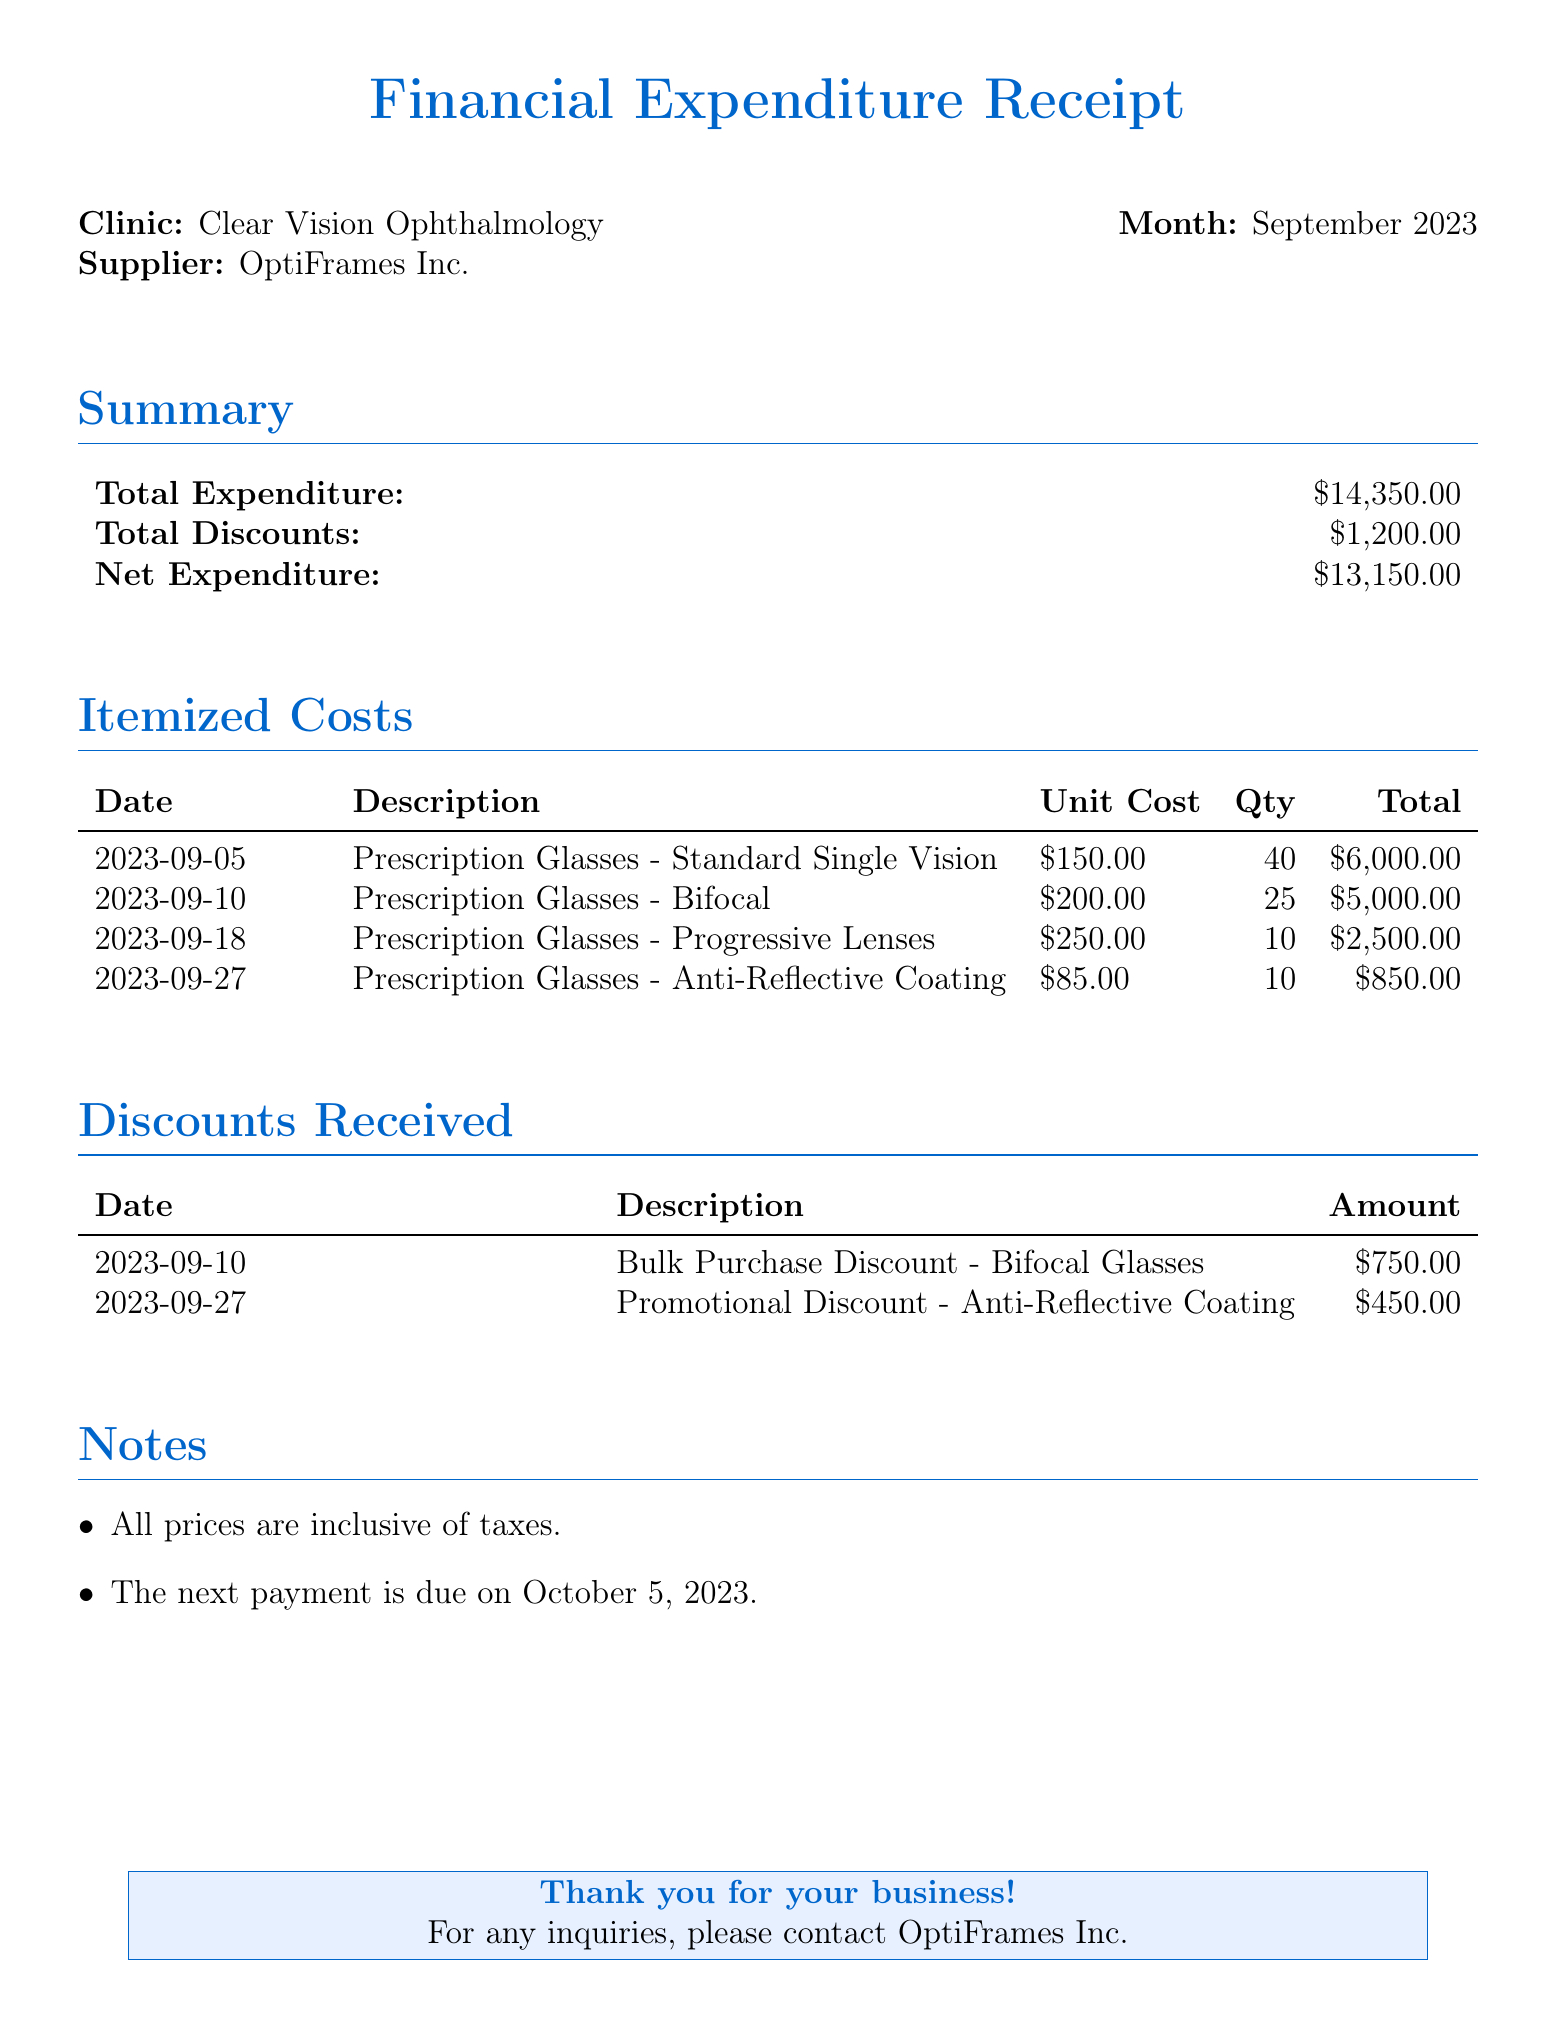What is the total expenditure? The total expenditure is listed in the summary section of the document.
Answer: $14,350.00 What is the net expenditure? The net expenditure is the total expenditure minus total discounts, as shown in the summary.
Answer: $13,150.00 Who is the supplier? The supplier's name is mentioned at the top of the document.
Answer: OptiFrames Inc What was the unit cost of bifocal glasses? The unit cost for bifocal glasses can be found in the itemized costs section.
Answer: $200.00 How many prescription glasses were purchased with anti-reflective coating? The quantity for anti-reflective coating glasses is listed in the itemized costs table.
Answer: 10 What date was the bulk purchase discount received? The date is specified in the discounts received section of the document.
Answer: 2023-09-10 What is the total amount of discounts received? The total discounts can be calculated by adding all the amounts listed in the discounts section.
Answer: $1,200.00 What type of document is this? This document provides a summary of financial expenditures related to purchases.
Answer: Financial Expenditure Receipt When is the next payment due? The due date for the next payment is noted in the notes section at the end of the document.
Answer: October 5, 2023 